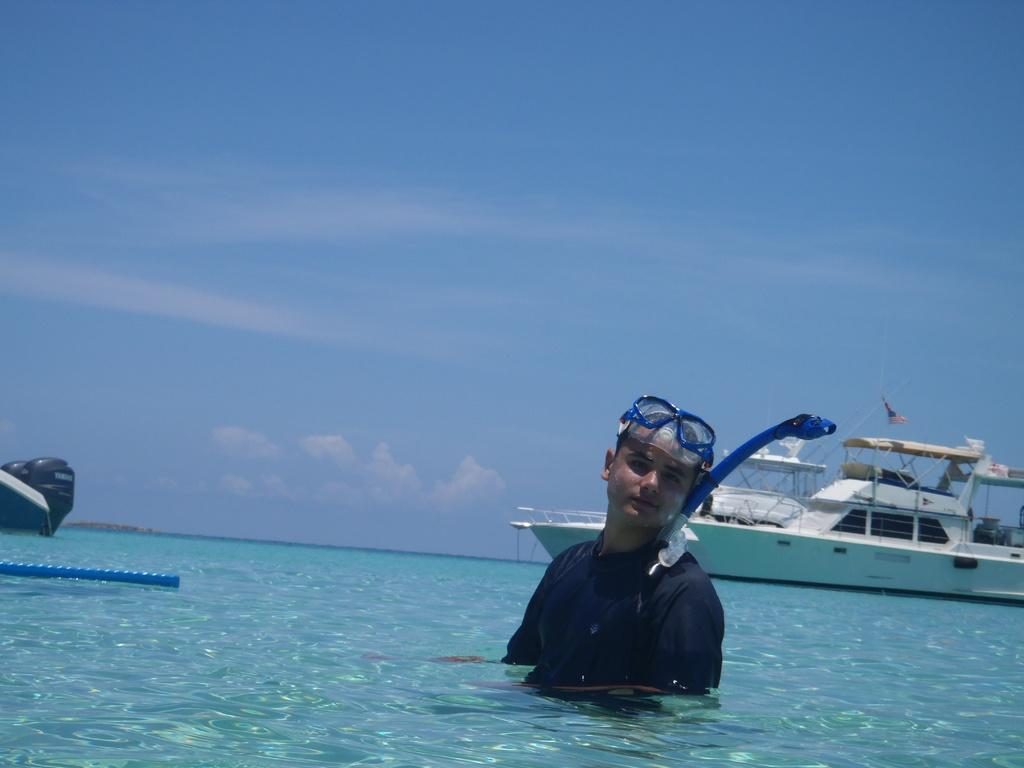What is the man in the image doing? The man is swimming in the image. What is at the bottom of the image? There is water at the bottom of the image. What can be seen in the background of the image? There is a boat in the background of the image. What is visible at the top of the image? The sky is visible at the top of the image. How many chickens are on the boat in the image? There are no chickens present in the image, and the boat is in the background. 